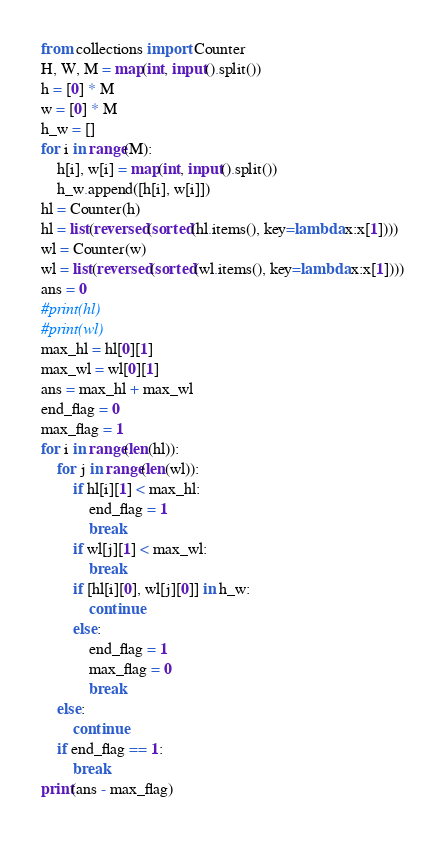Convert code to text. <code><loc_0><loc_0><loc_500><loc_500><_Python_>from collections import Counter
H, W, M = map(int, input().split())
h = [0] * M
w = [0] * M
h_w = []
for i in range(M):
    h[i], w[i] = map(int, input().split())
    h_w.append([h[i], w[i]])
hl = Counter(h)
hl = list(reversed(sorted(hl.items(), key=lambda x:x[1])))
wl = Counter(w)
wl = list(reversed(sorted(wl.items(), key=lambda x:x[1])))
ans = 0
#print(hl)
#print(wl)
max_hl = hl[0][1]
max_wl = wl[0][1]
ans = max_hl + max_wl
end_flag = 0
max_flag = 1
for i in range(len(hl)):
    for j in range(len(wl)):
        if hl[i][1] < max_hl:
            end_flag = 1
            break
        if wl[j][1] < max_wl:
            break
        if [hl[i][0], wl[j][0]] in h_w:
            continue
        else:
            end_flag = 1
            max_flag = 0
            break
    else:
        continue
    if end_flag == 1:
        break
print(ans - max_flag)
</code> 